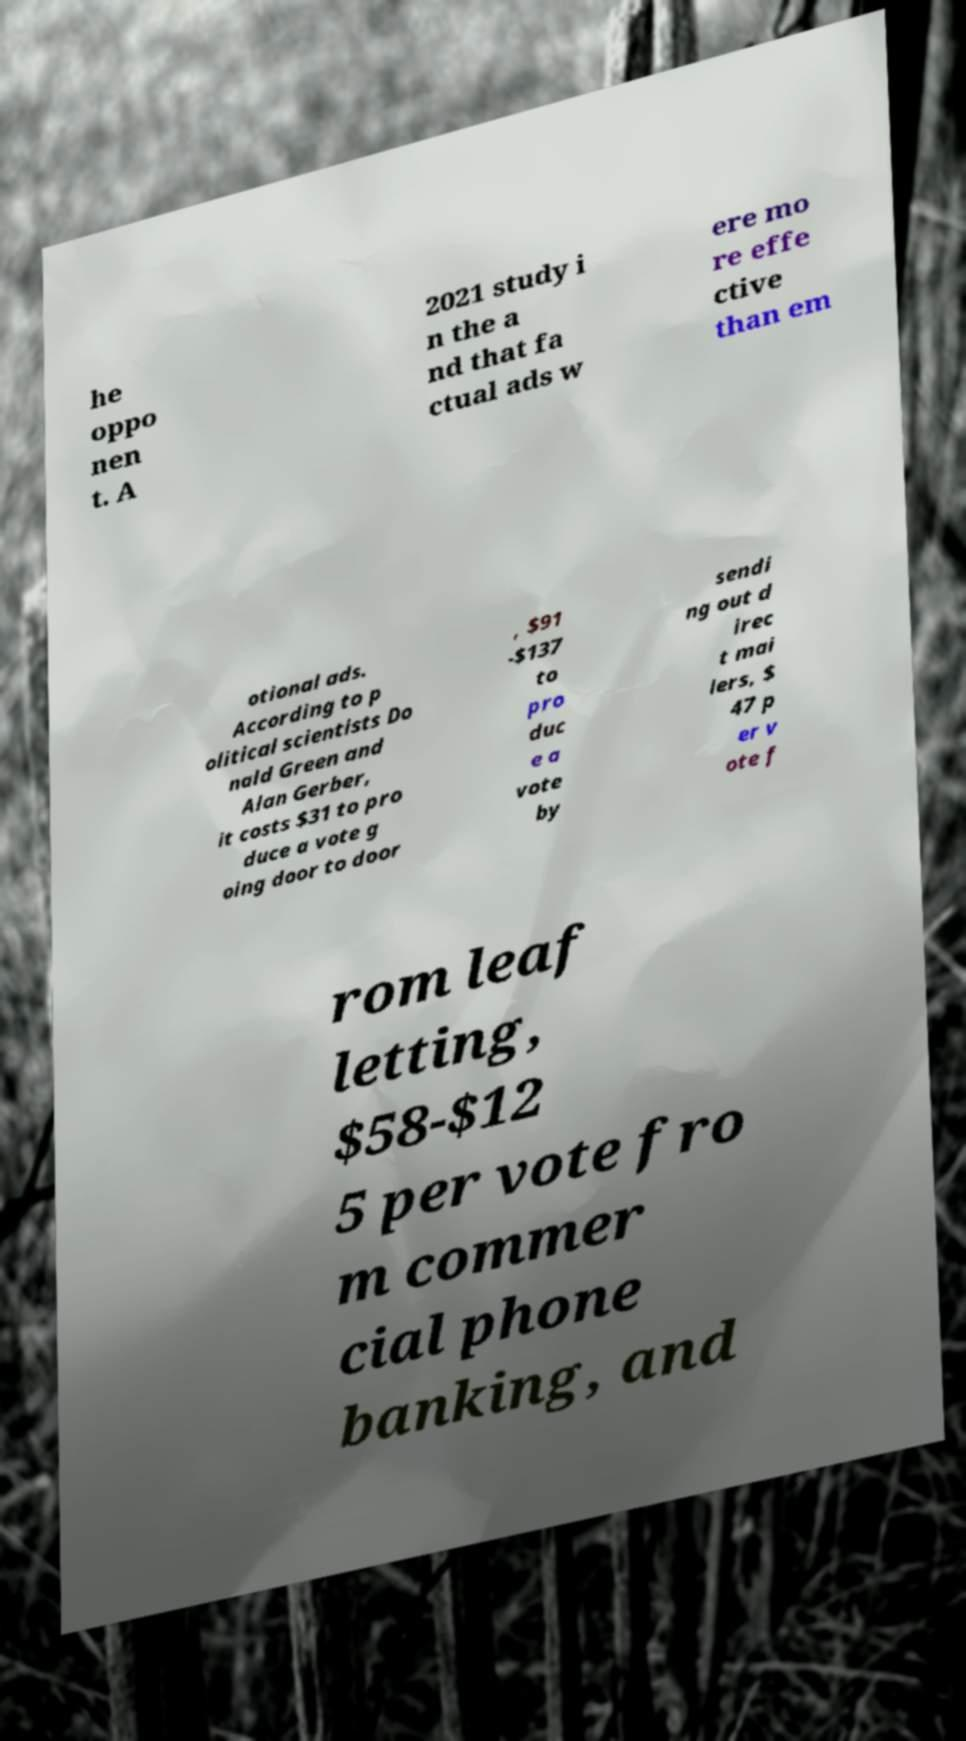Could you assist in decoding the text presented in this image and type it out clearly? he oppo nen t. A 2021 study i n the a nd that fa ctual ads w ere mo re effe ctive than em otional ads. According to p olitical scientists Do nald Green and Alan Gerber, it costs $31 to pro duce a vote g oing door to door , $91 -$137 to pro duc e a vote by sendi ng out d irec t mai lers, $ 47 p er v ote f rom leaf letting, $58-$12 5 per vote fro m commer cial phone banking, and 